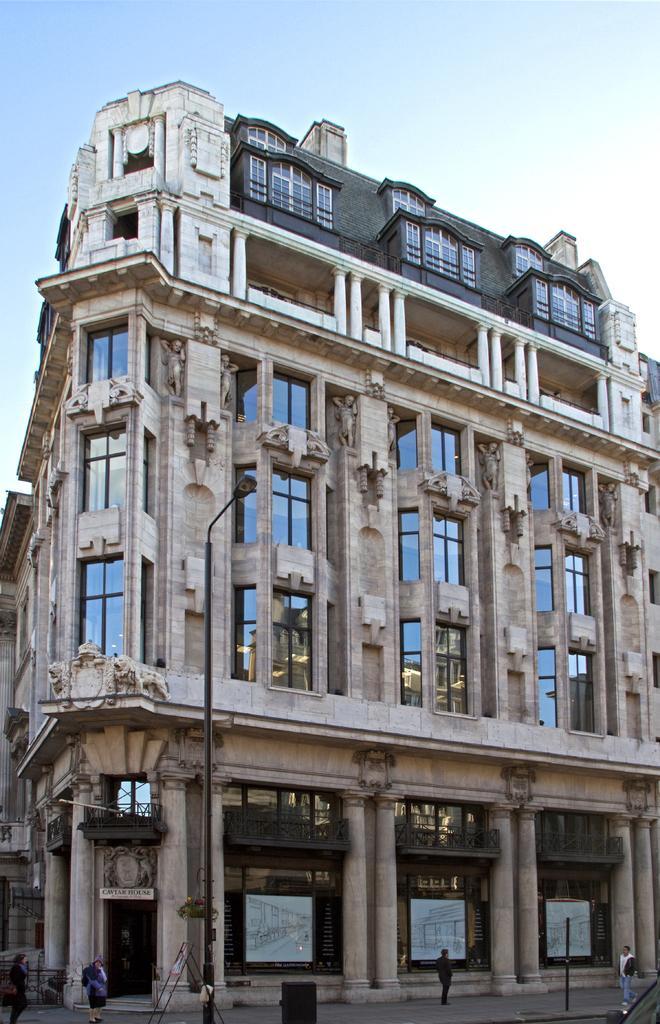Please provide a concise description of this image. In this image in the front there are persons walking, there are poles and in the background there is a building and the sky is cloudy. 